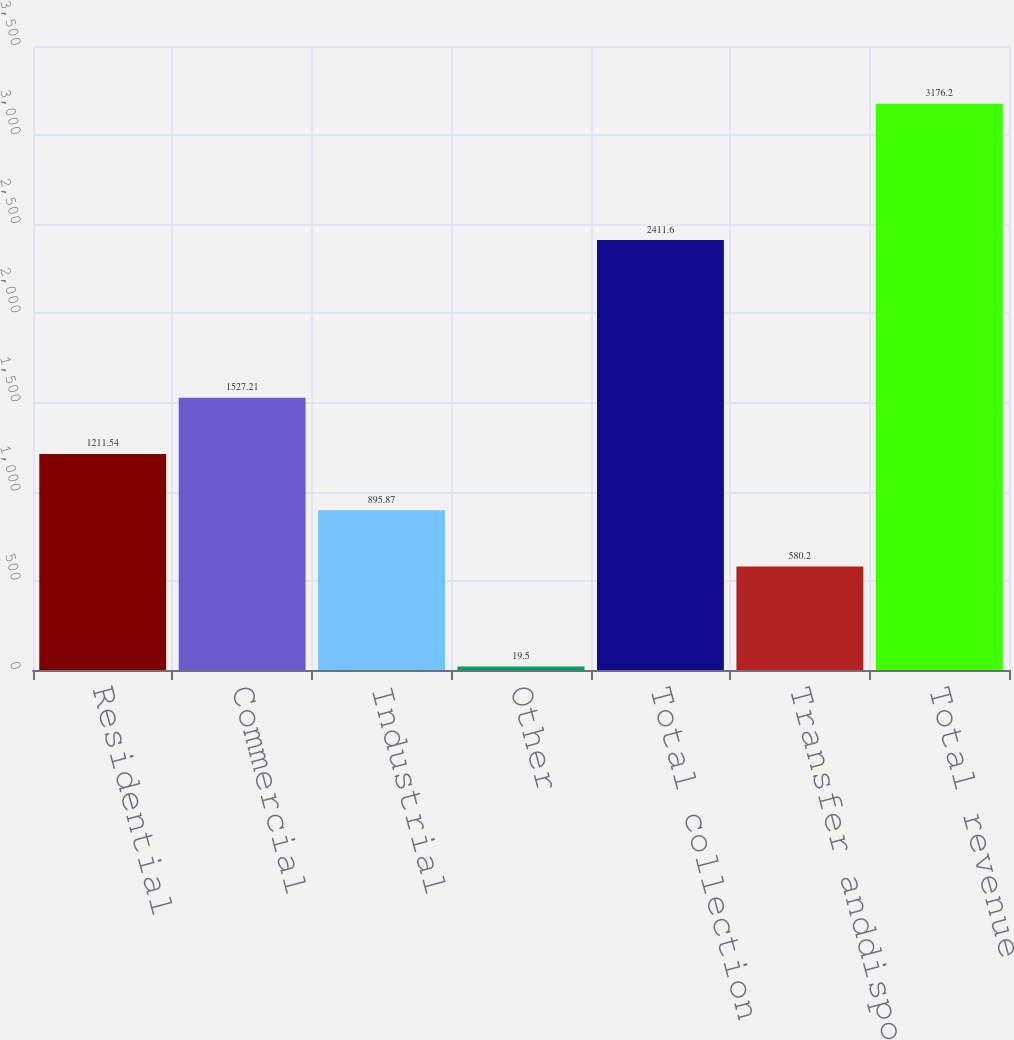Convert chart to OTSL. <chart><loc_0><loc_0><loc_500><loc_500><bar_chart><fcel>Residential<fcel>Commercial<fcel>Industrial<fcel>Other<fcel>Total collection<fcel>Transfer anddisposal net<fcel>Total revenue<nl><fcel>1211.54<fcel>1527.21<fcel>895.87<fcel>19.5<fcel>2411.6<fcel>580.2<fcel>3176.2<nl></chart> 